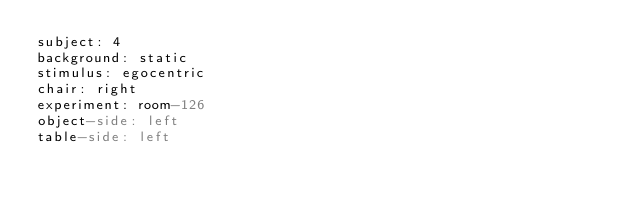Convert code to text. <code><loc_0><loc_0><loc_500><loc_500><_YAML_>subject: 4
background: static
stimulus: egocentric
chair: right
experiment: room-126
object-side: left
table-side: left
</code> 